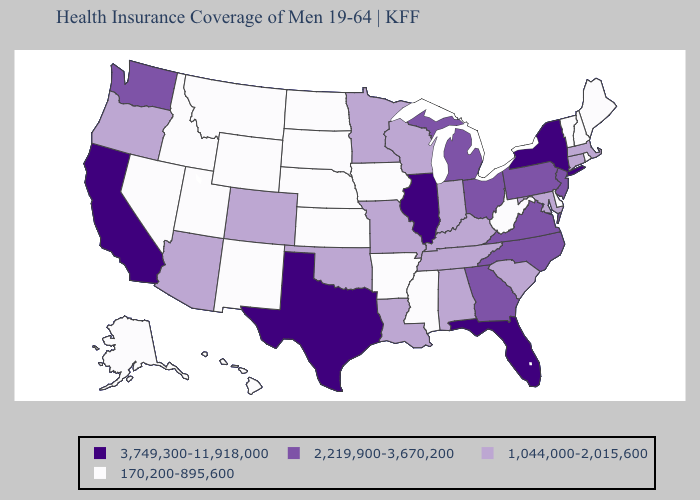Does Ohio have the same value as North Carolina?
Short answer required. Yes. What is the lowest value in states that border North Dakota?
Quick response, please. 170,200-895,600. What is the highest value in the MidWest ?
Write a very short answer. 3,749,300-11,918,000. Name the states that have a value in the range 3,749,300-11,918,000?
Quick response, please. California, Florida, Illinois, New York, Texas. Does Texas have the same value as Florida?
Keep it brief. Yes. Does the map have missing data?
Concise answer only. No. What is the value of Wyoming?
Write a very short answer. 170,200-895,600. Does Connecticut have the same value as Tennessee?
Give a very brief answer. Yes. What is the value of Idaho?
Keep it brief. 170,200-895,600. What is the highest value in the South ?
Short answer required. 3,749,300-11,918,000. Does the first symbol in the legend represent the smallest category?
Concise answer only. No. What is the value of Texas?
Quick response, please. 3,749,300-11,918,000. What is the value of Minnesota?
Concise answer only. 1,044,000-2,015,600. What is the value of Georgia?
Be succinct. 2,219,900-3,670,200. What is the value of Idaho?
Write a very short answer. 170,200-895,600. 